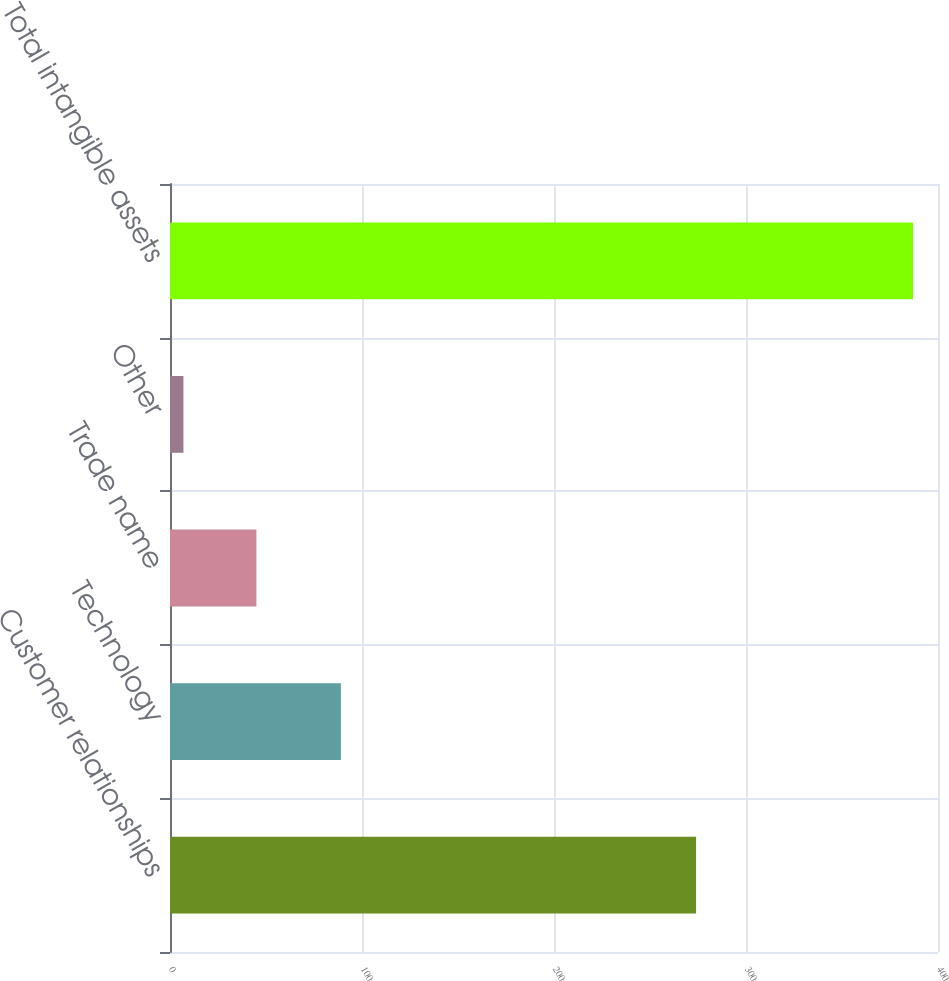Convert chart. <chart><loc_0><loc_0><loc_500><loc_500><bar_chart><fcel>Customer relationships<fcel>Technology<fcel>Trade name<fcel>Other<fcel>Total intangible assets<nl><fcel>274<fcel>89<fcel>45<fcel>7<fcel>387<nl></chart> 